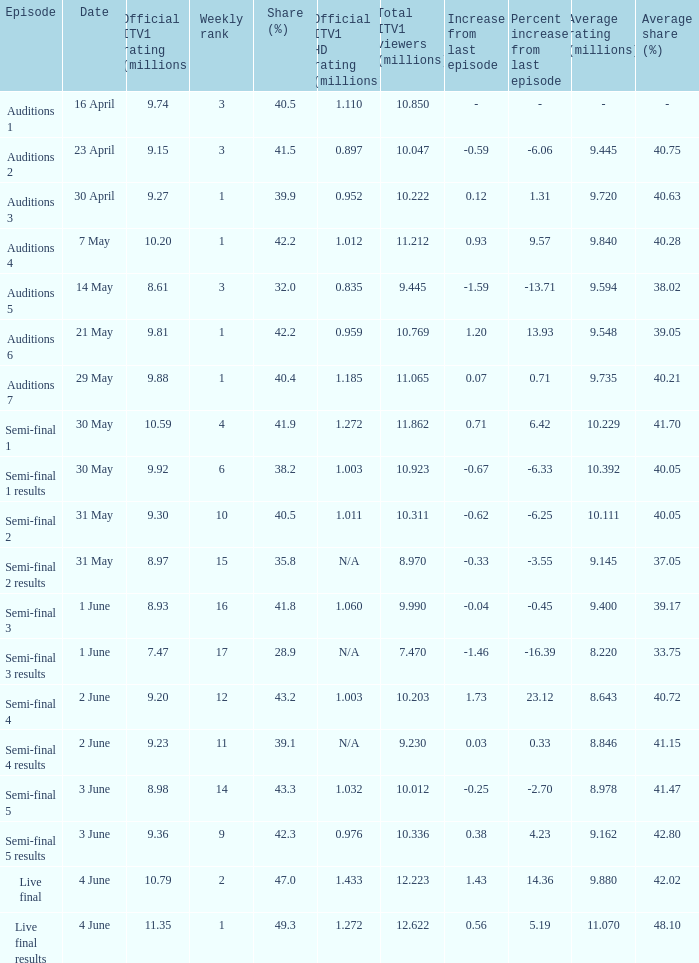Would you be able to parse every entry in this table? {'header': ['Episode', 'Date', 'Official ITV1 rating (millions)', 'Weekly rank', 'Share (%)', 'Official ITV1 HD rating (millions)', 'Total ITV1 viewers (millions)', 'Increase from last episode', 'Percent increase from last episode', 'Average rating (millions)', 'Average share (%)'], 'rows': [['Auditions 1', '16 April', '9.74', '3', '40.5', '1.110', '10.850', '-', '-', '-', '-'], ['Auditions 2', '23 April', '9.15', '3', '41.5', '0.897', '10.047', '-0.59', '-6.06', '9.445', '40.75'], ['Auditions 3', '30 April', '9.27', '1', '39.9', '0.952', '10.222', '0.12', '1.31', '9.720', '40.63'], ['Auditions 4', '7 May', '10.20', '1', '42.2', '1.012', '11.212', '0.93', '9.57', '9.840', '40.28'], ['Auditions 5', '14 May', '8.61', '3', '32.0', '0.835', '9.445', '-1.59', '-13.71', '9.594', '38.02'], ['Auditions 6', '21 May', '9.81', '1', '42.2', '0.959', '10.769', '1.20', '13.93', '9.548', '39.05'], ['Auditions 7', '29 May', '9.88', '1', '40.4', '1.185', '11.065', '0.07', '0.71', '9.735', '40.21'], ['Semi-final 1', '30 May', '10.59', '4', '41.9', '1.272', '11.862', '0.71', '6.42', '10.229', '41.70'], ['Semi-final 1 results', '30 May', '9.92', '6', '38.2', '1.003', '10.923', '-0.67', '-6.33', '10.392', '40.05'], ['Semi-final 2', '31 May', '9.30', '10', '40.5', '1.011', '10.311', '-0.62', '-6.25', '10.111', '40.05'], ['Semi-final 2 results', '31 May', '8.97', '15', '35.8', 'N/A', '8.970', '-0.33', '-3.55', '9.145', '37.05'], ['Semi-final 3', '1 June', '8.93', '16', '41.8', '1.060', '9.990', '-0.04', '-0.45', '9.400', '39.17'], ['Semi-final 3 results', '1 June', '7.47', '17', '28.9', 'N/A', '7.470', '-1.46', '-16.39', '8.220', '33.75'], ['Semi-final 4', '2 June', '9.20', '12', '43.2', '1.003', '10.203', '1.73', '23.12', '8.643', '40.72'], ['Semi-final 4 results', '2 June', '9.23', '11', '39.1', 'N/A', '9.230', '0.03', '0.33', '8.846', '41.15'], ['Semi-final 5', '3 June', '8.98', '14', '43.3', '1.032', '10.012', '-0.25', '-2.70', '8.978', '41.47'], ['Semi-final 5 results', '3 June', '9.36', '9', '42.3', '0.976', '10.336', '0.38', '4.23', '9.162', '42.80'], ['Live final', '4 June', '10.79', '2', '47.0', '1.433', '12.223', '1.43', '14.36', '9.880', '42.02'], ['Live final results', '4 June', '11.35', '1', '49.3', '1.272', '12.622', '0.56', '5.19', '11.070', '48.10']]} When was the episode that had a share (%) of 41.5? 23 April. 